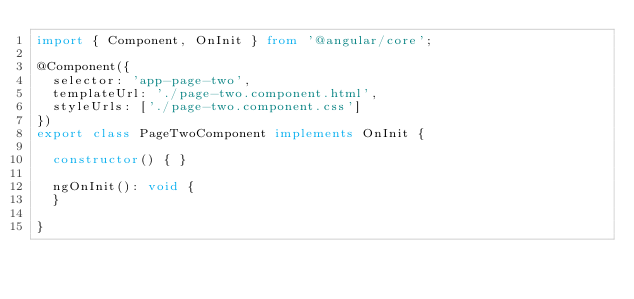Convert code to text. <code><loc_0><loc_0><loc_500><loc_500><_TypeScript_>import { Component, OnInit } from '@angular/core';

@Component({
  selector: 'app-page-two',
  templateUrl: './page-two.component.html',
  styleUrls: ['./page-two.component.css']
})
export class PageTwoComponent implements OnInit {

  constructor() { }

  ngOnInit(): void {
  }

}
</code> 